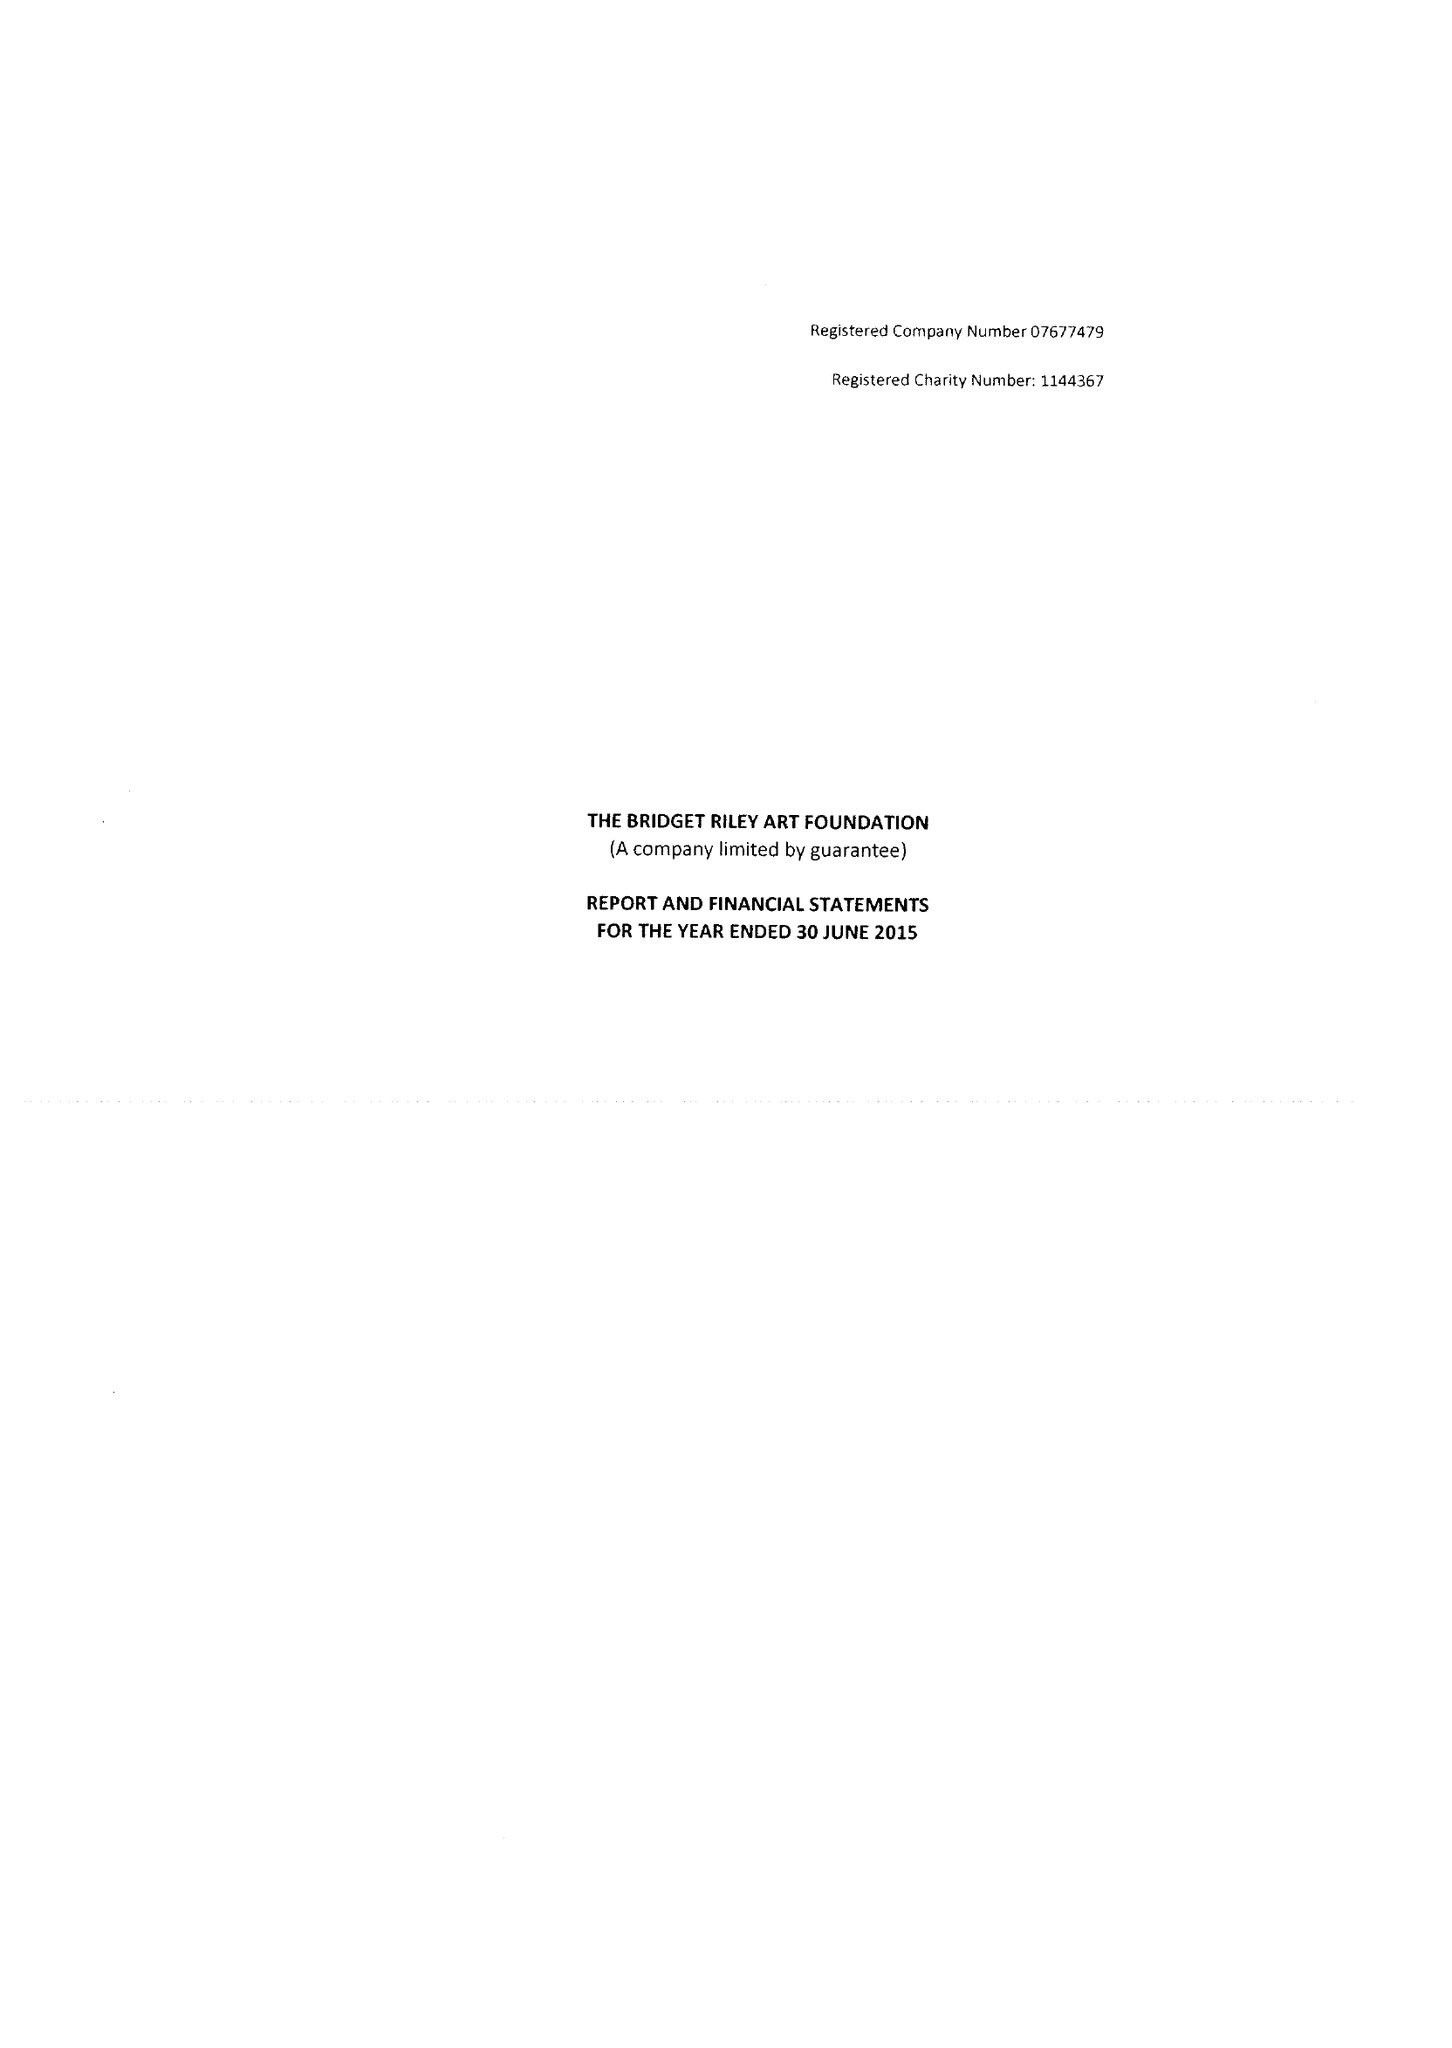What is the value for the address__postcode?
Answer the question using a single word or phrase. W11 4SL 